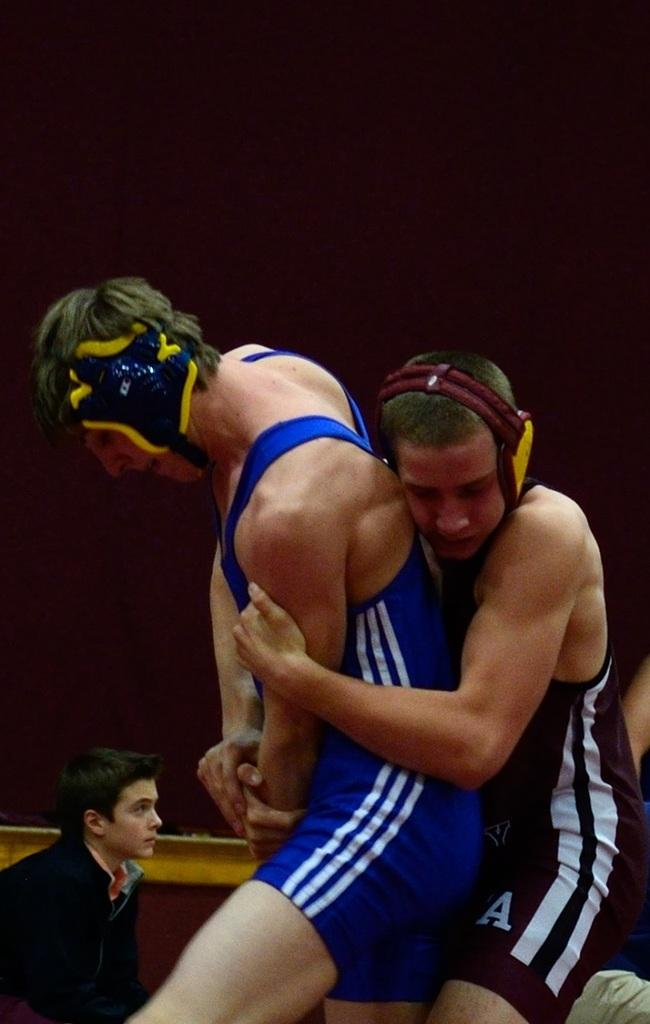How many people are in the image? There are people in the image. What are the people in the image doing? One person is holding another person. What is visible in the background of the image? There is a wall in the background of the image. How many bulbs are hanging from the ceiling in the image? There is no mention of any bulbs in the image. What type of boys are present in the image? There is no reference to boys in the image; it only mentions people. 